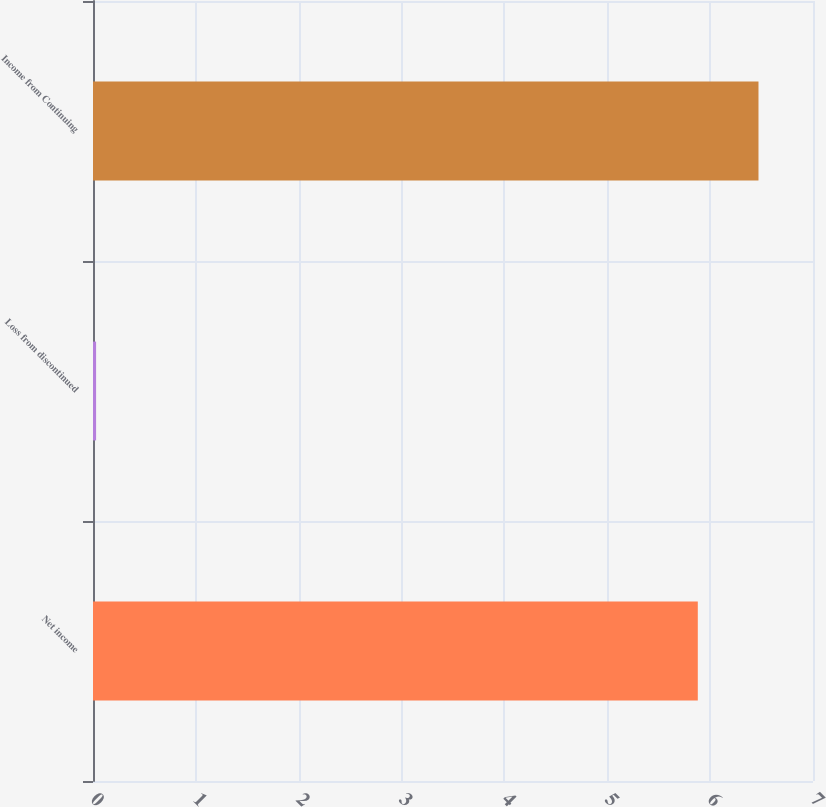<chart> <loc_0><loc_0><loc_500><loc_500><bar_chart><fcel>Net income<fcel>Loss from discontinued<fcel>Income from Continuing<nl><fcel>5.88<fcel>0.03<fcel>6.47<nl></chart> 